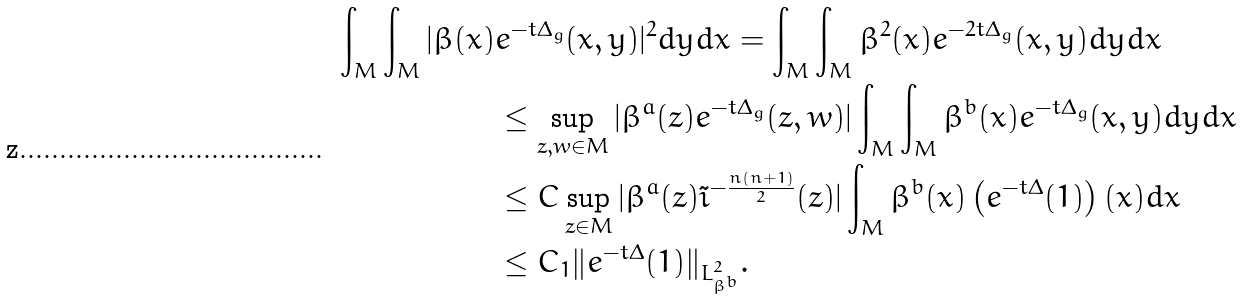<formula> <loc_0><loc_0><loc_500><loc_500>\int _ { M } \int _ { M } | \beta ( x ) & e ^ { - t \Delta _ { g } } ( x , y ) | ^ { 2 } d y d x = \int _ { M } \int _ { M } \beta ^ { 2 } ( x ) e ^ { - 2 t \Delta _ { g } } ( x , y ) d y d x \\ & \leq \sup _ { z , w \in M } | \beta ^ { a } ( z ) e ^ { - t \Delta _ { g } } ( z , w ) | \int _ { M } \int _ { M } \beta ^ { b } ( x ) e ^ { - t \Delta _ { g } } ( x , y ) d y d x \\ & \leq C \sup _ { z \in M } | \beta ^ { a } ( z ) \tilde { \imath } ^ { - \frac { n ( n + 1 ) } { 2 } } ( z ) | \int _ { M } \beta ^ { b } ( x ) \left ( e ^ { - t \Delta } ( 1 ) \right ) ( x ) d x \\ & \leq C _ { 1 } \| e ^ { - t \Delta } ( 1 ) \| _ { L ^ { 2 } _ { \beta ^ { b } } } .</formula> 